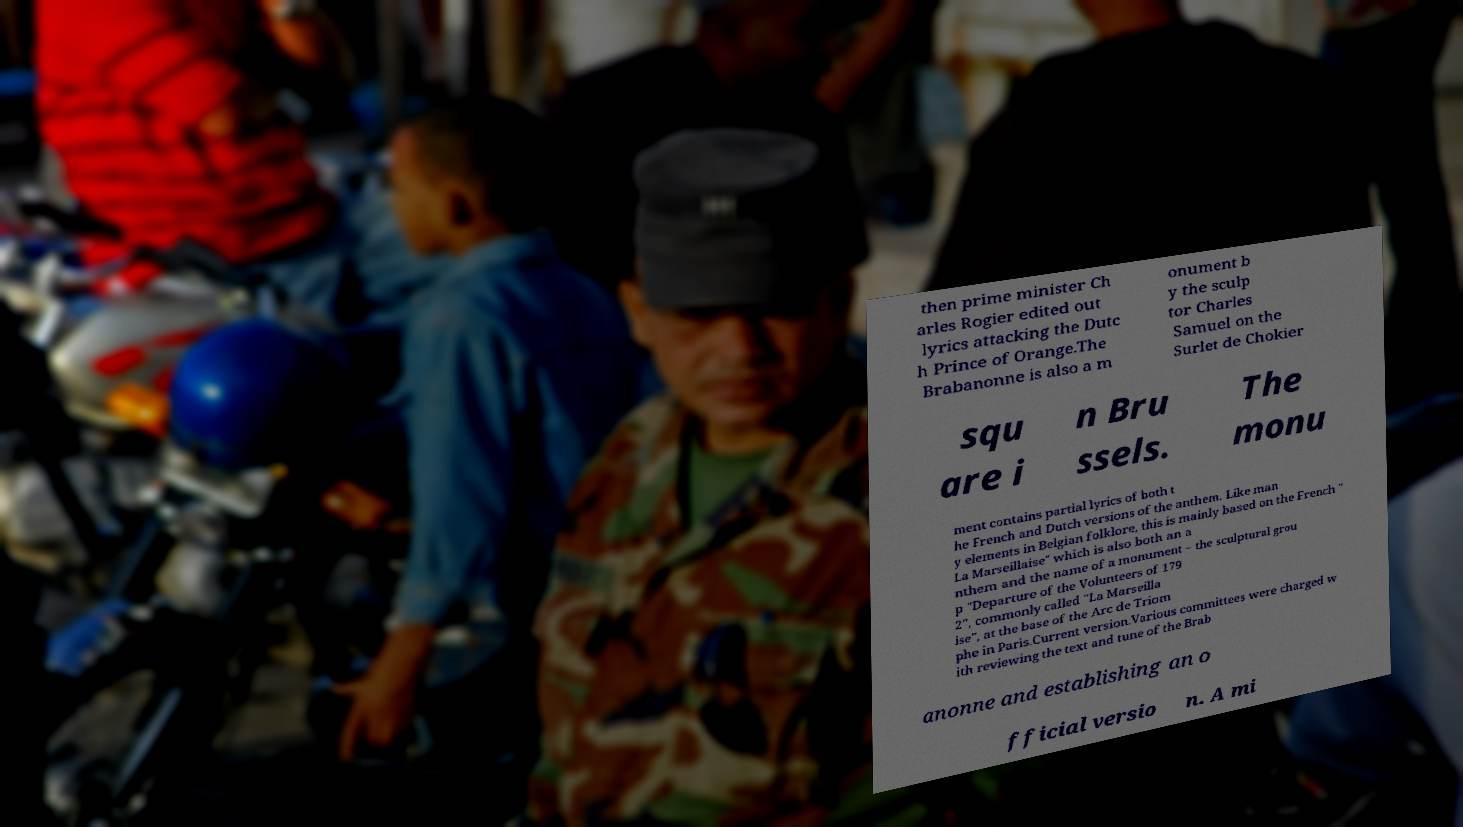There's text embedded in this image that I need extracted. Can you transcribe it verbatim? then prime minister Ch arles Rogier edited out lyrics attacking the Dutc h Prince of Orange.The Brabanonne is also a m onument b y the sculp tor Charles Samuel on the Surlet de Chokier squ are i n Bru ssels. The monu ment contains partial lyrics of both t he French and Dutch versions of the anthem. Like man y elements in Belgian folklore, this is mainly based on the French " La Marseillaise" which is also both an a nthem and the name of a monument – the sculptural grou p "Departure of the Volunteers of 179 2", commonly called "La Marseilla ise", at the base of the Arc de Triom phe in Paris.Current version.Various committees were charged w ith reviewing the text and tune of the Brab anonne and establishing an o fficial versio n. A mi 